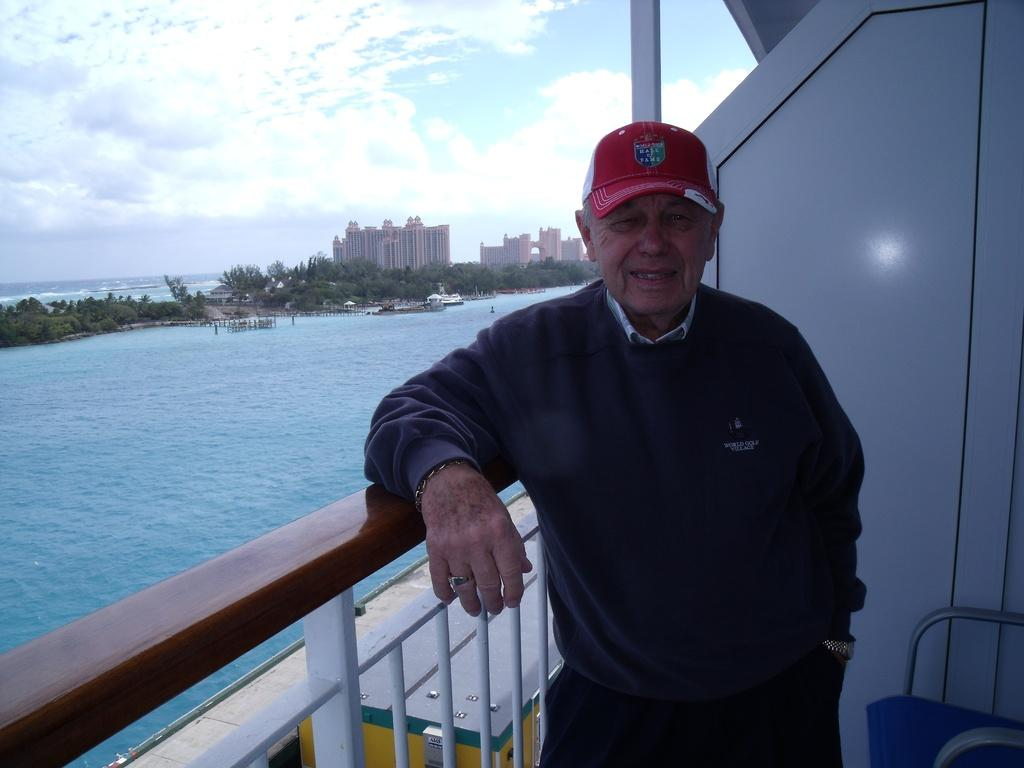What can be seen in the image? There is a person in the image. What is the person wearing on their wrist? The person is wearing a watch. What is the person wearing on their head? The person is wearing a cap. Where is the person standing in relation to the railing? The person is standing near a railing. What is present on the right side of the image? There is a wall and a chair on the right side of the image. What can be seen in the background of the image? Water, buildings, and the sky are visible in the background of the image. What is the condition of the sky in the image? The sky is visible with clouds in the background of the image. What type of cushion is being used by the person in the image? There is no cushion present in the image. How does the faucet in the image contribute to the overall scene? There is no faucet present in the image. 